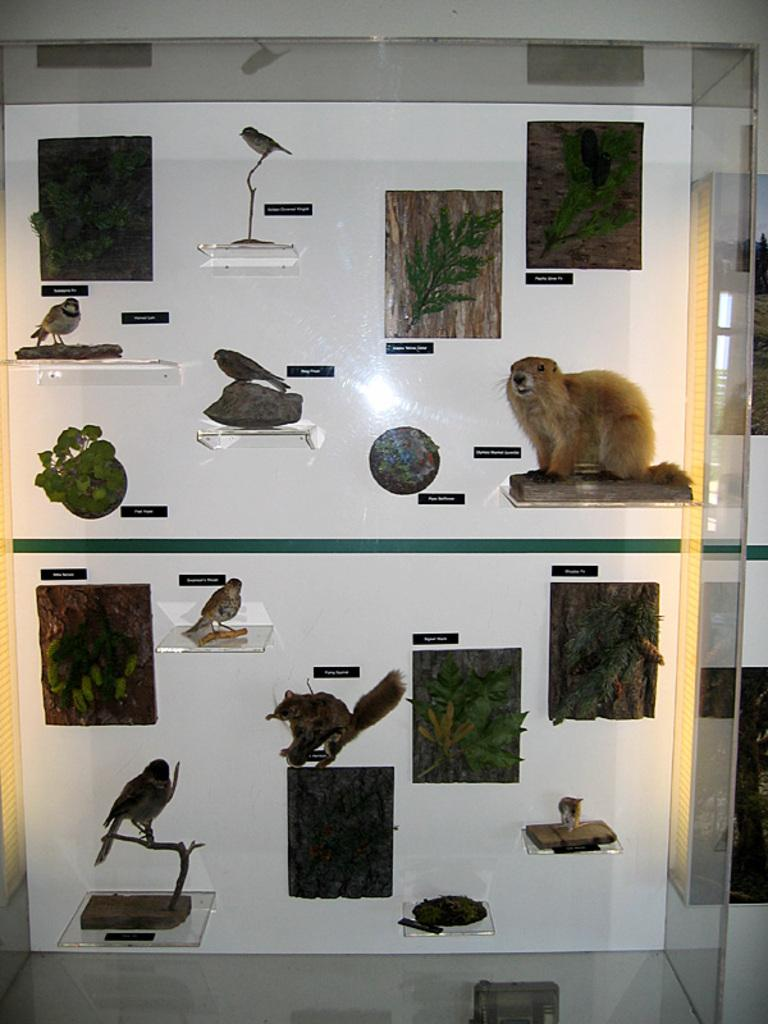What can be seen on the wall in the image? There are posts on the wall in the image. What types of toys are present in the image? There are toys of animals and toys of birds in the image. Where are the toys located in the image? The toys are on shelves in the image. What is the curve of the pencil in the image? There is no pencil present in the image. How does the expansion of the toys affect the shelves in the image? There is no indication of expansion affecting the shelves in the image, as the toys are stationary on the shelves. 